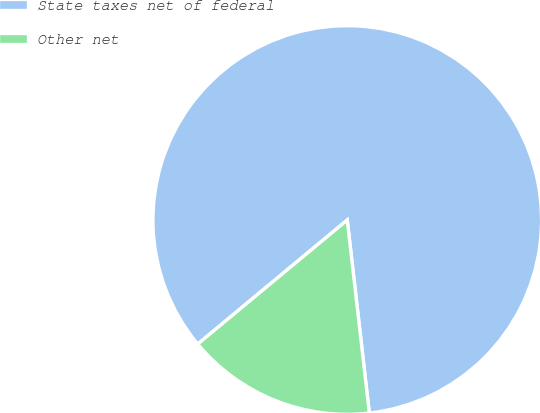<chart> <loc_0><loc_0><loc_500><loc_500><pie_chart><fcel>State taxes net of federal<fcel>Other net<nl><fcel>84.21%<fcel>15.79%<nl></chart> 